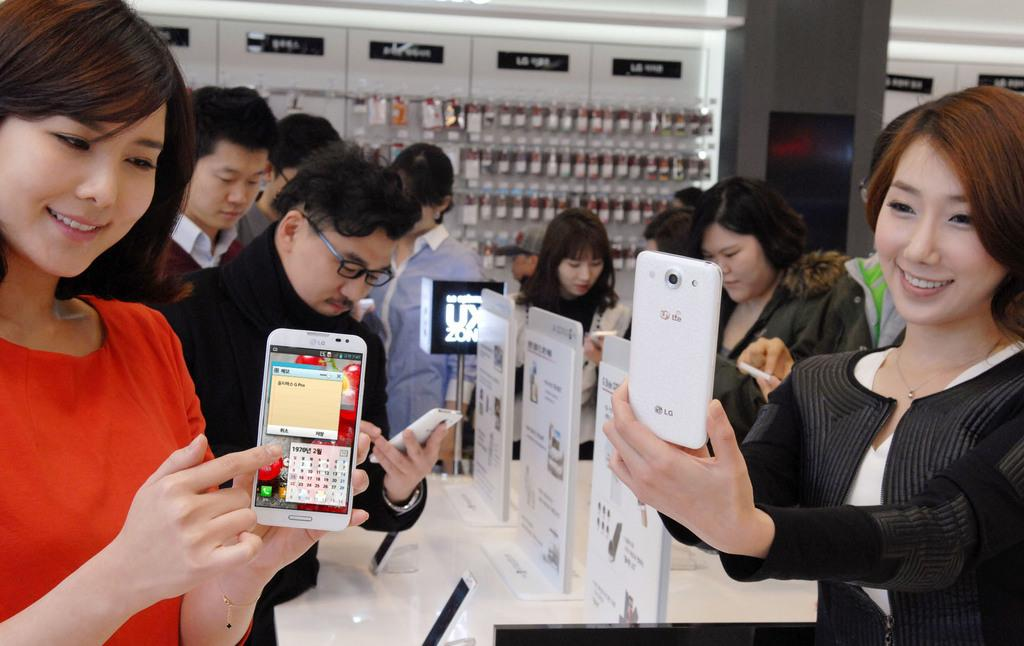How many people are in the group depicted in the image? There is a group of people in the image, but the exact number is not specified. What are some people in the group doing? Some people in the group are holding mobile phones. What type of location does the image appear to depict? The image appears to depict a store. What is the weight of the partner in the image? There is no partner present in the image, so it is not possible to determine their weight. 